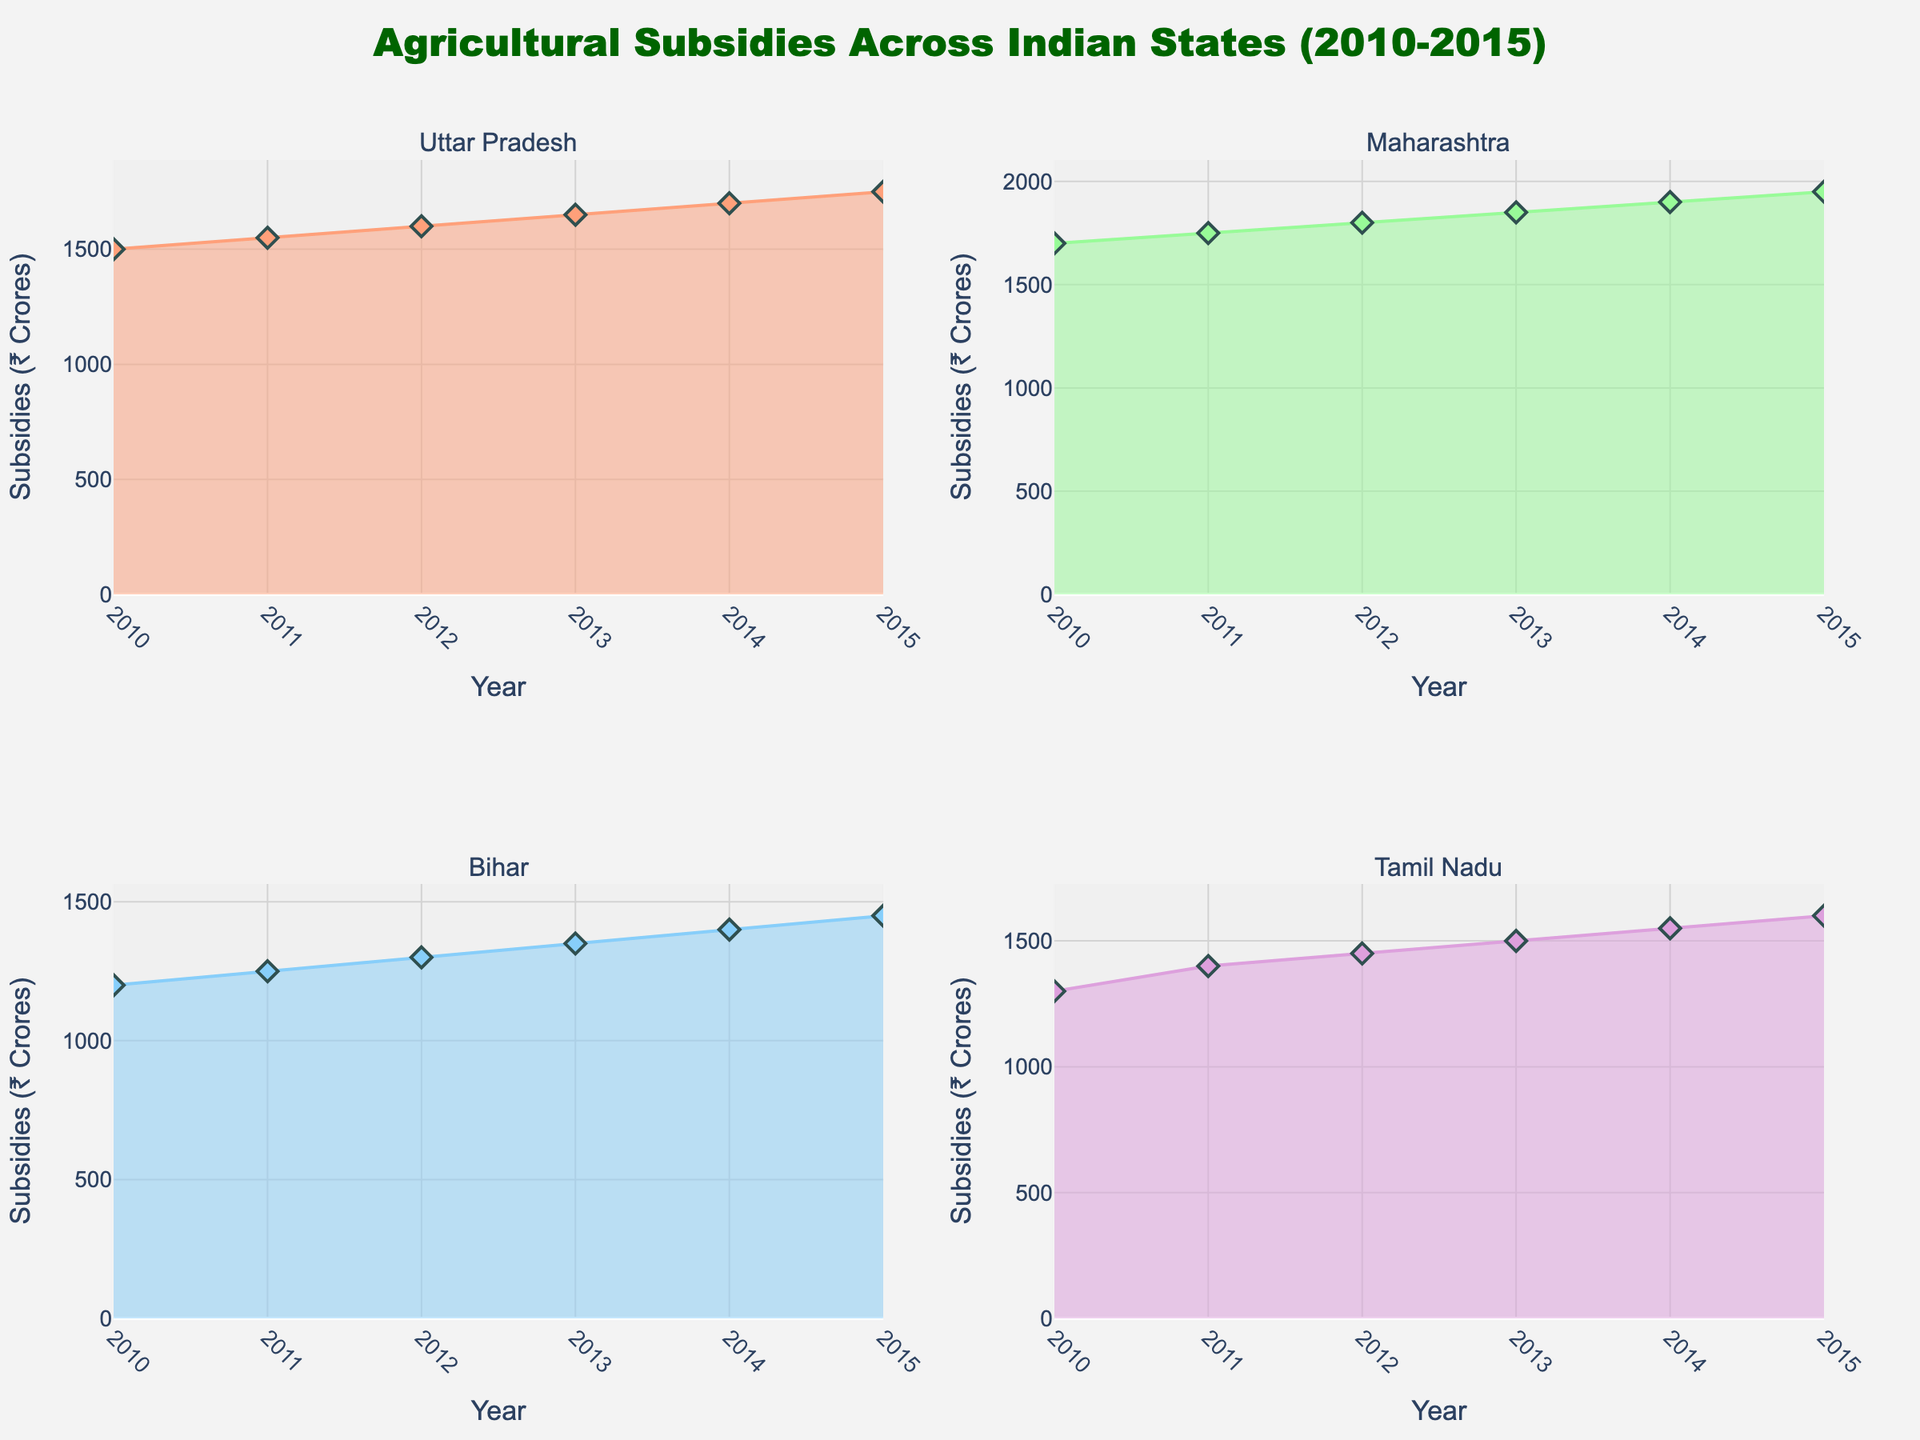what is the title of the figure? The title of the figure is located at the top center of the chart. It provides a succinct description of the visualized data.
Answer: Agricultural Subsidies Across Indian States (2010-2015) How many subplots are there in the figure? The figure is divided into smaller plots to represent different states, each subplot is titled with the state's name. The total number of subplots can be identified by counting these titled sections.
Answer: 4 Which state showed the highest agricultural subsidies in 2015? By looking at the subplot for each state and examining the year 2015, we can compare the agricultural subsidies values.
Answer: Maharashtra In which year did Tamil Nadu have the highest agricultural subsidies, and who was the political leader at that time? Look at Tamil Nadu's subplot and identify the year with the peak value for subsidies; the hover text will reveal the political leader for that specific year.
Answer: 2015, Jayalalithaa How did the agricultural subsidies in Uttar Pradesh change from 2010 to 2015? Examine the subplot for Uttar Pradesh and compare the subsidies value at the start in 2010 with that at the end in 2015 to describe the overall trend.
Answer: Increased from 1500 to 1750 Which leader was associated with the lowest subsidy value in Bihar and what was that value? Review the subsidies values in the Bihar subplot and find the minimum value, then use the hover text to identify the leader associated with that value.
Answer: Nitish Kumar, 1200 Compare the trend of agricultural subsidies between Uttar Pradesh and Bihar from 2010 to 2015. Check the subplots for both states, paying attention to the start and end values as well as any peaks or declines over the years. Describe how they increase or decrease.
Answer: Both increased, but Uttar Pradesh showed a more consistent rise while Bihar showed a more gradual increase What is the main color used in the subplot for Maharashtra? The subplots are colored differently, and identifying the main color helps distinguish between the states. Maharashtra's subplot has a particular colored area chart.
Answer: Light blue How does the total agricultural subsidies for Tamil Nadu compare to Bihar over the 2010-2015 period? For both Tamil Nadu and Bihar, sum the subsidy values from each year within the given period and compare these totals.
Answer: Tamil Nadu had higher total subsidies than Bihar 